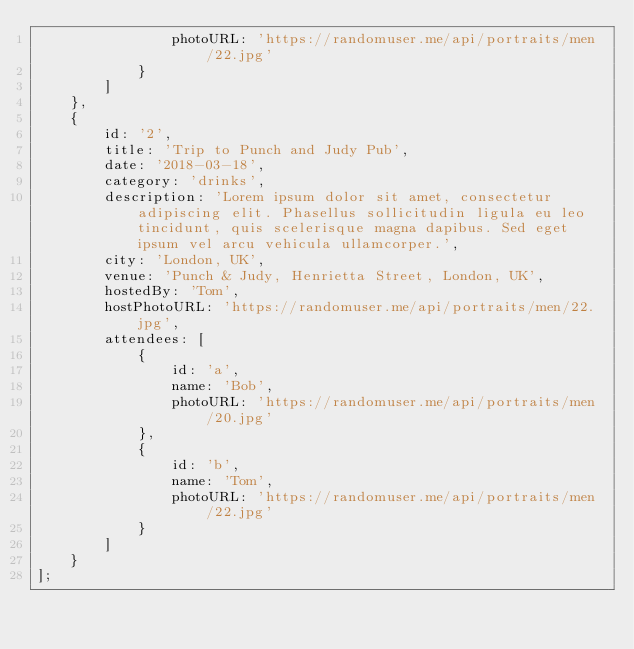<code> <loc_0><loc_0><loc_500><loc_500><_JavaScript_>                photoURL: 'https://randomuser.me/api/portraits/men/22.jpg'
            }
        ]
    },
    {
        id: '2',
        title: 'Trip to Punch and Judy Pub',
        date: '2018-03-18',
        category: 'drinks',
        description: 'Lorem ipsum dolor sit amet, consectetur adipiscing elit. Phasellus sollicitudin ligula eu leo tincidunt, quis scelerisque magna dapibus. Sed eget ipsum vel arcu vehicula ullamcorper.',
        city: 'London, UK',
        venue: 'Punch & Judy, Henrietta Street, London, UK',
        hostedBy: 'Tom',
        hostPhotoURL: 'https://randomuser.me/api/portraits/men/22.jpg',
        attendees: [
            {
                id: 'a',
                name: 'Bob',
                photoURL: 'https://randomuser.me/api/portraits/men/20.jpg'
            },
            {
                id: 'b',
                name: 'Tom',
                photoURL: 'https://randomuser.me/api/portraits/men/22.jpg'
            }
        ]
    }
];
</code> 